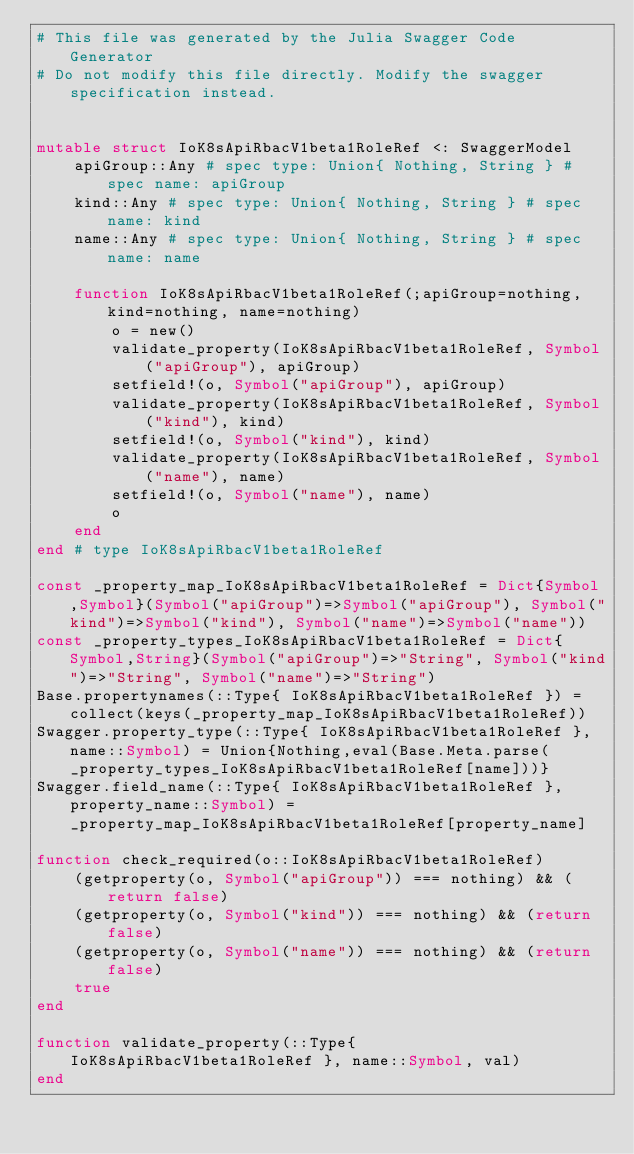<code> <loc_0><loc_0><loc_500><loc_500><_Julia_># This file was generated by the Julia Swagger Code Generator
# Do not modify this file directly. Modify the swagger specification instead.


mutable struct IoK8sApiRbacV1beta1RoleRef <: SwaggerModel
    apiGroup::Any # spec type: Union{ Nothing, String } # spec name: apiGroup
    kind::Any # spec type: Union{ Nothing, String } # spec name: kind
    name::Any # spec type: Union{ Nothing, String } # spec name: name

    function IoK8sApiRbacV1beta1RoleRef(;apiGroup=nothing, kind=nothing, name=nothing)
        o = new()
        validate_property(IoK8sApiRbacV1beta1RoleRef, Symbol("apiGroup"), apiGroup)
        setfield!(o, Symbol("apiGroup"), apiGroup)
        validate_property(IoK8sApiRbacV1beta1RoleRef, Symbol("kind"), kind)
        setfield!(o, Symbol("kind"), kind)
        validate_property(IoK8sApiRbacV1beta1RoleRef, Symbol("name"), name)
        setfield!(o, Symbol("name"), name)
        o
    end
end # type IoK8sApiRbacV1beta1RoleRef

const _property_map_IoK8sApiRbacV1beta1RoleRef = Dict{Symbol,Symbol}(Symbol("apiGroup")=>Symbol("apiGroup"), Symbol("kind")=>Symbol("kind"), Symbol("name")=>Symbol("name"))
const _property_types_IoK8sApiRbacV1beta1RoleRef = Dict{Symbol,String}(Symbol("apiGroup")=>"String", Symbol("kind")=>"String", Symbol("name")=>"String")
Base.propertynames(::Type{ IoK8sApiRbacV1beta1RoleRef }) = collect(keys(_property_map_IoK8sApiRbacV1beta1RoleRef))
Swagger.property_type(::Type{ IoK8sApiRbacV1beta1RoleRef }, name::Symbol) = Union{Nothing,eval(Base.Meta.parse(_property_types_IoK8sApiRbacV1beta1RoleRef[name]))}
Swagger.field_name(::Type{ IoK8sApiRbacV1beta1RoleRef }, property_name::Symbol) =  _property_map_IoK8sApiRbacV1beta1RoleRef[property_name]

function check_required(o::IoK8sApiRbacV1beta1RoleRef)
    (getproperty(o, Symbol("apiGroup")) === nothing) && (return false)
    (getproperty(o, Symbol("kind")) === nothing) && (return false)
    (getproperty(o, Symbol("name")) === nothing) && (return false)
    true
end

function validate_property(::Type{ IoK8sApiRbacV1beta1RoleRef }, name::Symbol, val)
end
</code> 